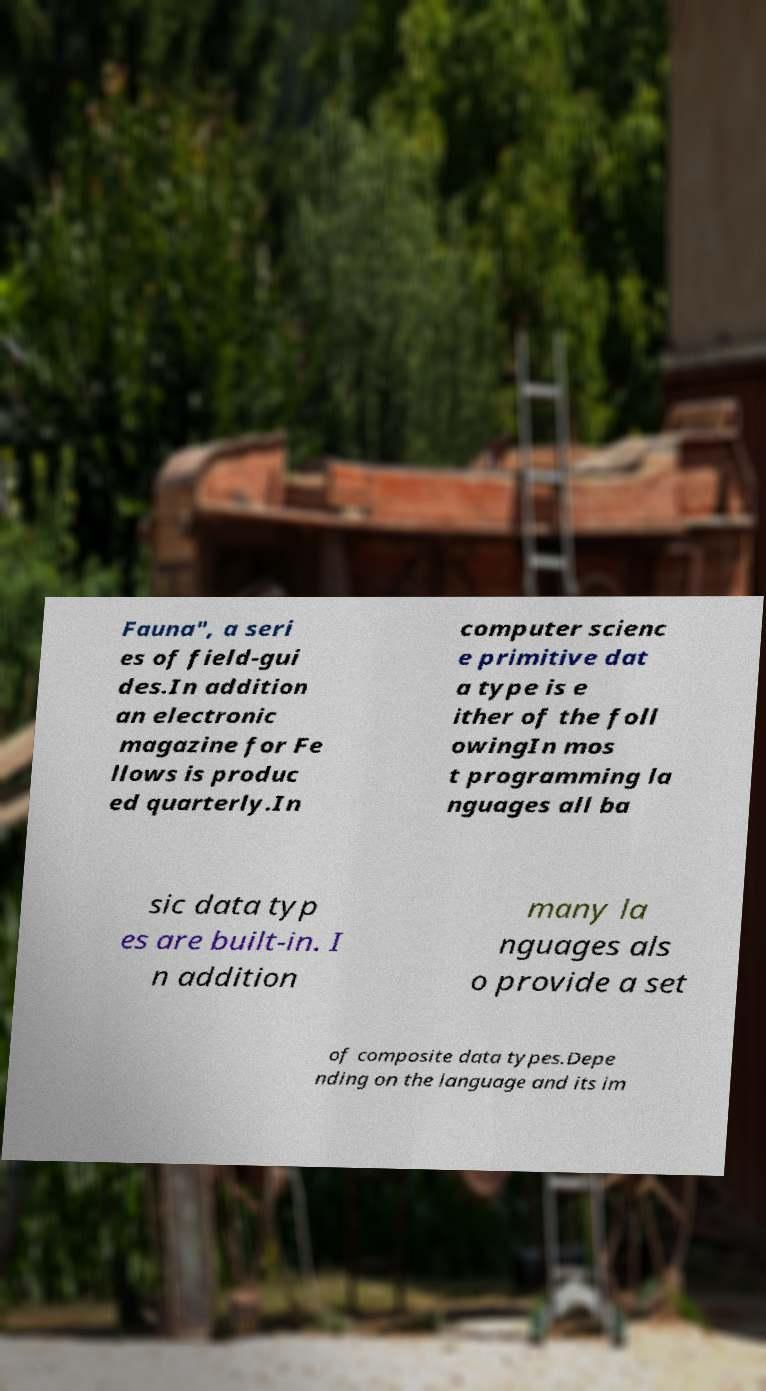Could you extract and type out the text from this image? Fauna", a seri es of field-gui des.In addition an electronic magazine for Fe llows is produc ed quarterly.In computer scienc e primitive dat a type is e ither of the foll owingIn mos t programming la nguages all ba sic data typ es are built-in. I n addition many la nguages als o provide a set of composite data types.Depe nding on the language and its im 